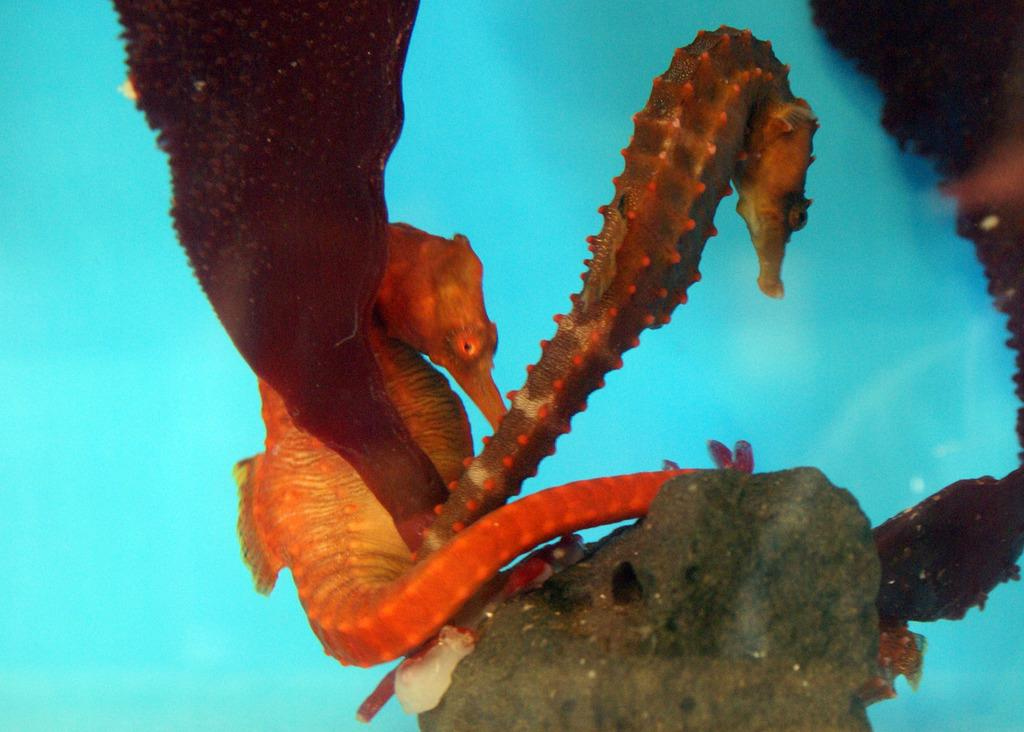What type of animals can be seen in the image? There are aquatic animals in the image. What color is the water in the image? The water in the image is blue. What type of vest can be seen on the aquatic animals in the image? There are no vests present on the aquatic animals in the image. Can you tell me how many bags are being carried by the aquatic animals in the image? There are no bags present in the image, as it features aquatic animals in water. 